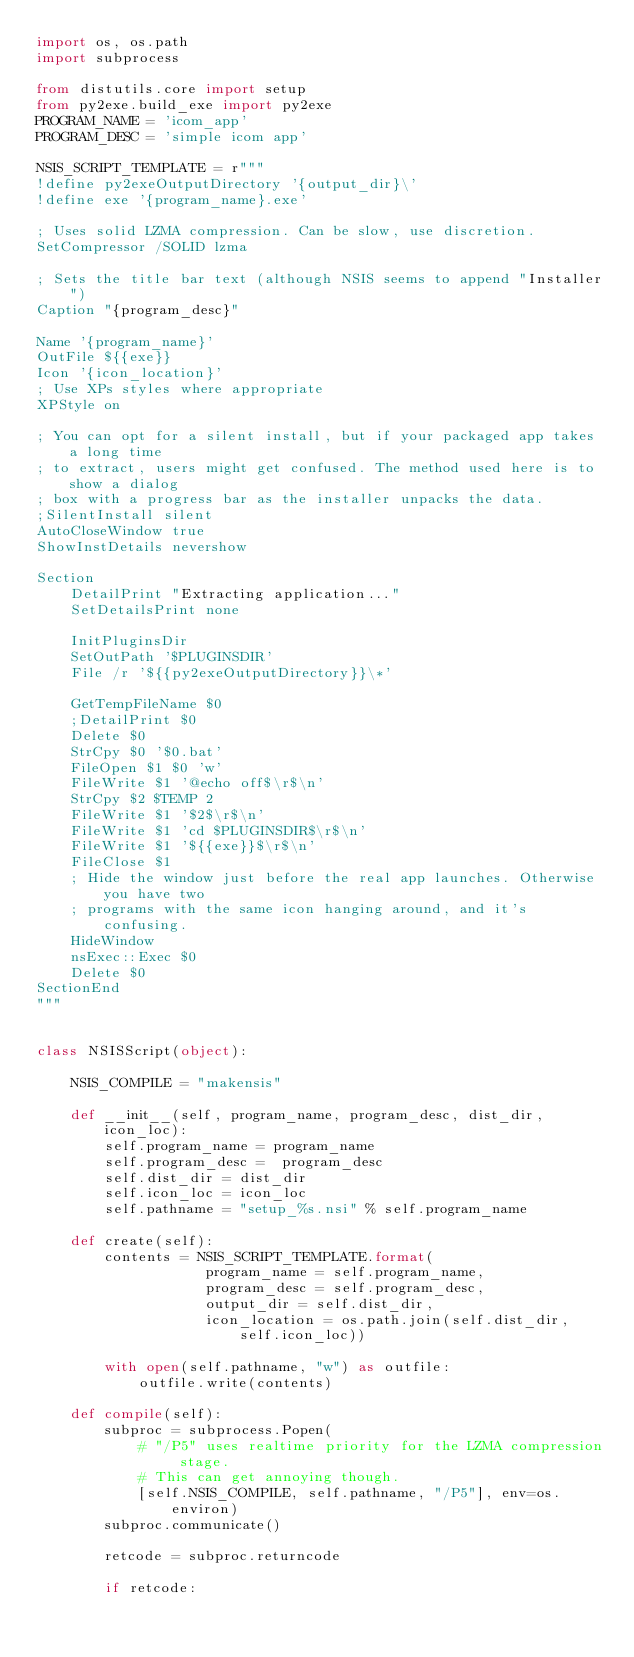Convert code to text. <code><loc_0><loc_0><loc_500><loc_500><_Python_>import os, os.path
import subprocess

from distutils.core import setup
from py2exe.build_exe import py2exe
PROGRAM_NAME = 'icom_app'
PROGRAM_DESC = 'simple icom app'

NSIS_SCRIPT_TEMPLATE = r"""
!define py2exeOutputDirectory '{output_dir}\'
!define exe '{program_name}.exe'

; Uses solid LZMA compression. Can be slow, use discretion.
SetCompressor /SOLID lzma

; Sets the title bar text (although NSIS seems to append "Installer")
Caption "{program_desc}"

Name '{program_name}'
OutFile ${{exe}}
Icon '{icon_location}'
; Use XPs styles where appropriate
XPStyle on

; You can opt for a silent install, but if your packaged app takes a long time
; to extract, users might get confused. The method used here is to show a dialog
; box with a progress bar as the installer unpacks the data.
;SilentInstall silent
AutoCloseWindow true
ShowInstDetails nevershow

Section
    DetailPrint "Extracting application..."
    SetDetailsPrint none
    
    InitPluginsDir
    SetOutPath '$PLUGINSDIR'
    File /r '${{py2exeOutputDirectory}}\*'

    GetTempFileName $0
    ;DetailPrint $0
    Delete $0
    StrCpy $0 '$0.bat'
    FileOpen $1 $0 'w'
    FileWrite $1 '@echo off$\r$\n'
    StrCpy $2 $TEMP 2
    FileWrite $1 '$2$\r$\n'
    FileWrite $1 'cd $PLUGINSDIR$\r$\n'
    FileWrite $1 '${{exe}}$\r$\n'
    FileClose $1
    ; Hide the window just before the real app launches. Otherwise you have two
    ; programs with the same icon hanging around, and it's confusing.
    HideWindow
    nsExec::Exec $0
    Delete $0
SectionEnd
"""


class NSISScript(object):
    
    NSIS_COMPILE = "makensis"
    
    def __init__(self, program_name, program_desc, dist_dir, icon_loc):
        self.program_name = program_name
        self.program_desc =  program_desc
        self.dist_dir = dist_dir
        self.icon_loc = icon_loc
        self.pathname = "setup_%s.nsi" % self.program_name
    
    def create(self):
        contents = NSIS_SCRIPT_TEMPLATE.format(
                    program_name = self.program_name,
                    program_desc = self.program_desc,
                    output_dir = self.dist_dir,
                    icon_location = os.path.join(self.dist_dir, self.icon_loc))

        with open(self.pathname, "w") as outfile:
            outfile.write(contents)

    def compile(self):
        subproc = subprocess.Popen(
            # "/P5" uses realtime priority for the LZMA compression stage.
            # This can get annoying though.
            [self.NSIS_COMPILE, self.pathname, "/P5"], env=os.environ)
        subproc.communicate()
        
        retcode = subproc.returncode
        
        if retcode:</code> 